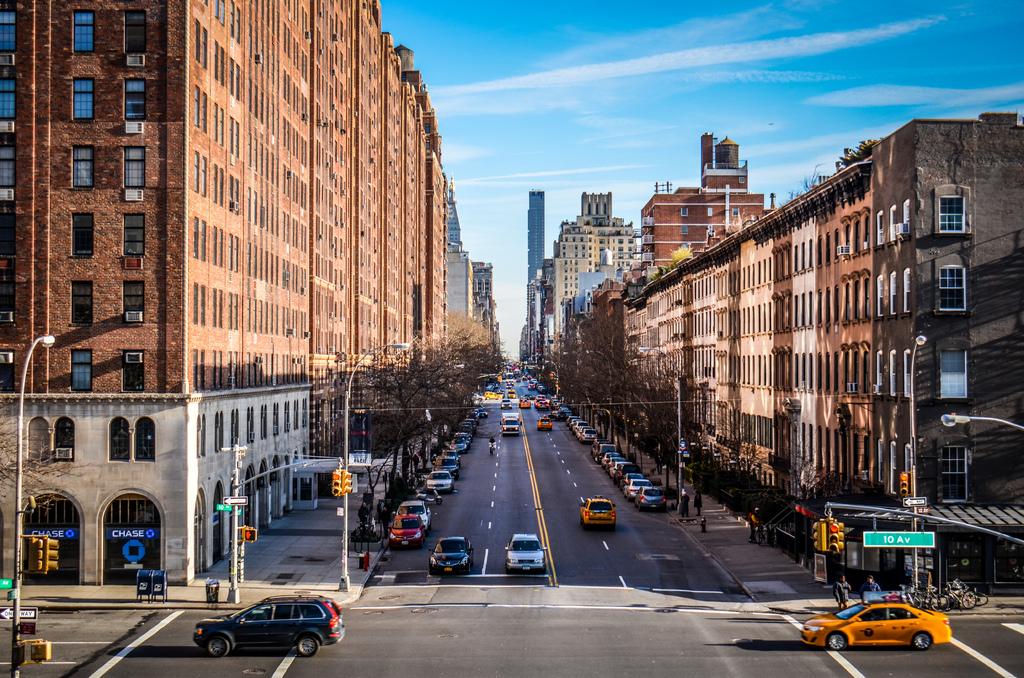What banking institution is located here?
Ensure brevity in your answer.  Chase. What is written on the street sign?
Your answer should be very brief. 10 av. 